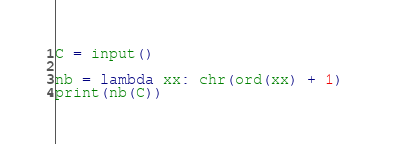Convert code to text. <code><loc_0><loc_0><loc_500><loc_500><_Python_>C = input()

nb = lambda xx: chr(ord(xx) + 1) 
print(nb(C))</code> 